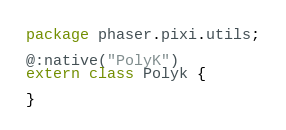Convert code to text. <code><loc_0><loc_0><loc_500><loc_500><_Haxe_>package phaser.pixi.utils;

@:native("PolyK")
extern class Polyk {
	
}
</code> 